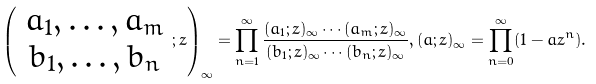<formula> <loc_0><loc_0><loc_500><loc_500>\left ( \begin{array} { c } a _ { 1 } , \dots , a _ { m } \\ b _ { 1 } , \dots , b _ { n } \end{array} ; z \right ) _ { \infty } = \prod _ { n = 1 } ^ { \infty } \frac { ( a _ { 1 } ; z ) _ { \infty } \cdots ( a _ { m } ; z ) _ { \infty } } { ( b _ { 1 } ; z ) _ { \infty } \cdots ( b _ { n } ; z ) _ { \infty } } , ( a ; z ) _ { \infty } = \prod _ { n = 0 } ^ { \infty } ( 1 - a z ^ { n } ) .</formula> 